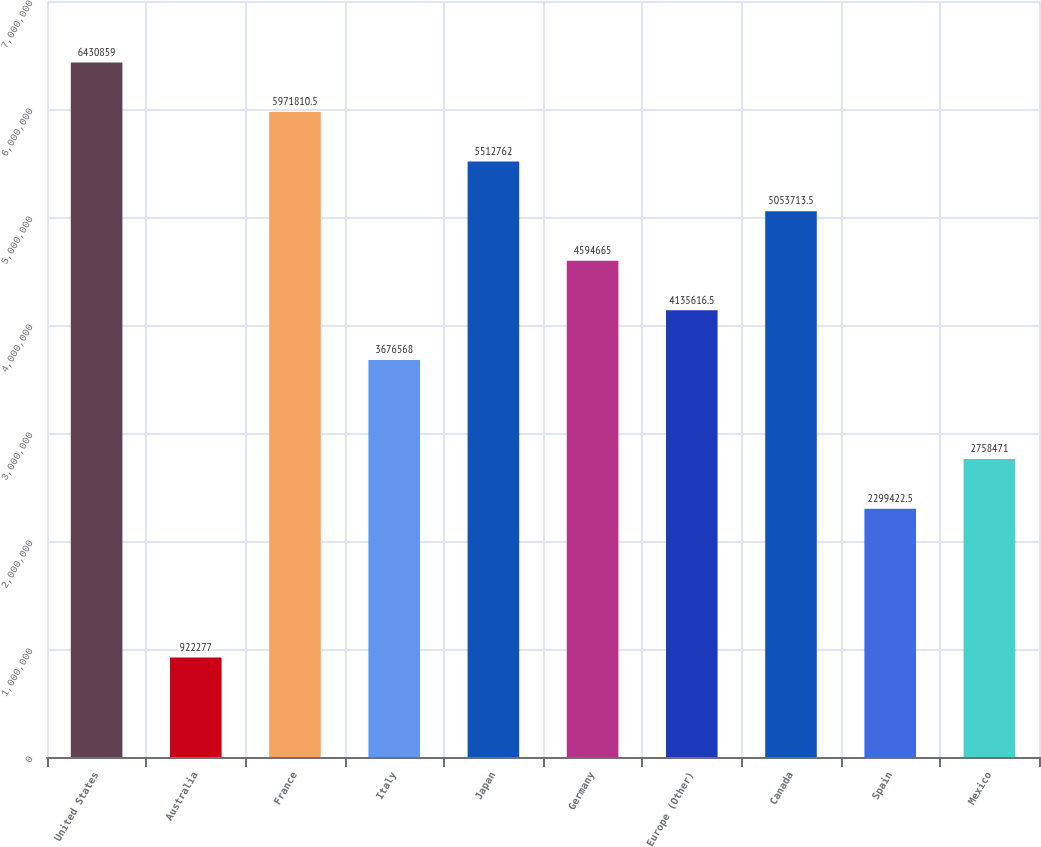Convert chart to OTSL. <chart><loc_0><loc_0><loc_500><loc_500><bar_chart><fcel>United States<fcel>Australia<fcel>France<fcel>Italy<fcel>Japan<fcel>Germany<fcel>Europe (Other)<fcel>Canada<fcel>Spain<fcel>Mexico<nl><fcel>6.43086e+06<fcel>922277<fcel>5.97181e+06<fcel>3.67657e+06<fcel>5.51276e+06<fcel>4.59466e+06<fcel>4.13562e+06<fcel>5.05371e+06<fcel>2.29942e+06<fcel>2.75847e+06<nl></chart> 